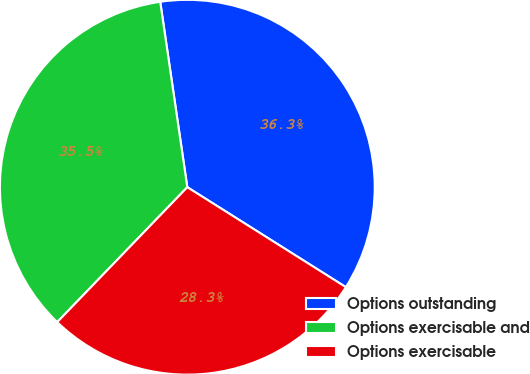Convert chart. <chart><loc_0><loc_0><loc_500><loc_500><pie_chart><fcel>Options outstanding<fcel>Options exercisable and<fcel>Options exercisable<nl><fcel>36.26%<fcel>35.48%<fcel>28.26%<nl></chart> 